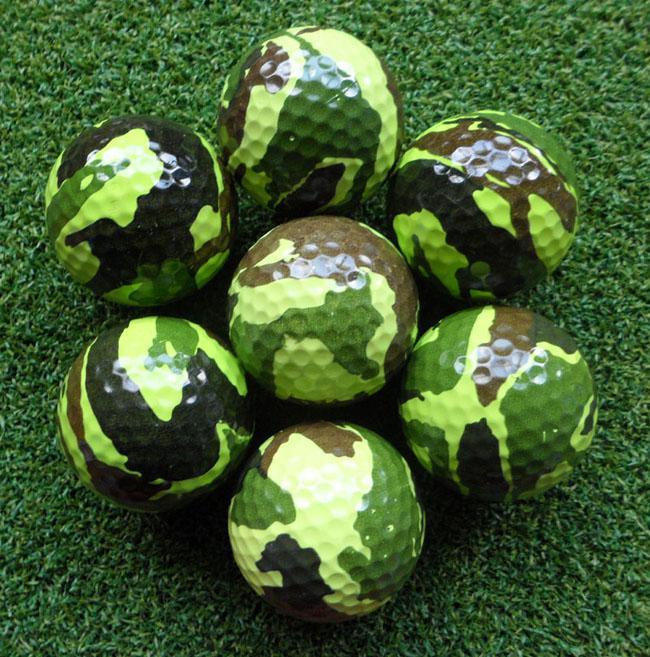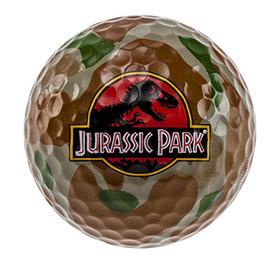The first image is the image on the left, the second image is the image on the right. Examine the images to the left and right. Is the description "The image on the right includes a box of three camo patterned golf balls, and the image on the left includes a group of three balls that are not in a package." accurate? Answer yes or no. No. 